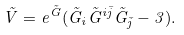Convert formula to latex. <formula><loc_0><loc_0><loc_500><loc_500>\tilde { V } = e ^ { \tilde { G } } ( \tilde { G } _ { i } \tilde { G } ^ { i \bar { j } } \tilde { G } _ { \bar { j } } - 3 ) .</formula> 